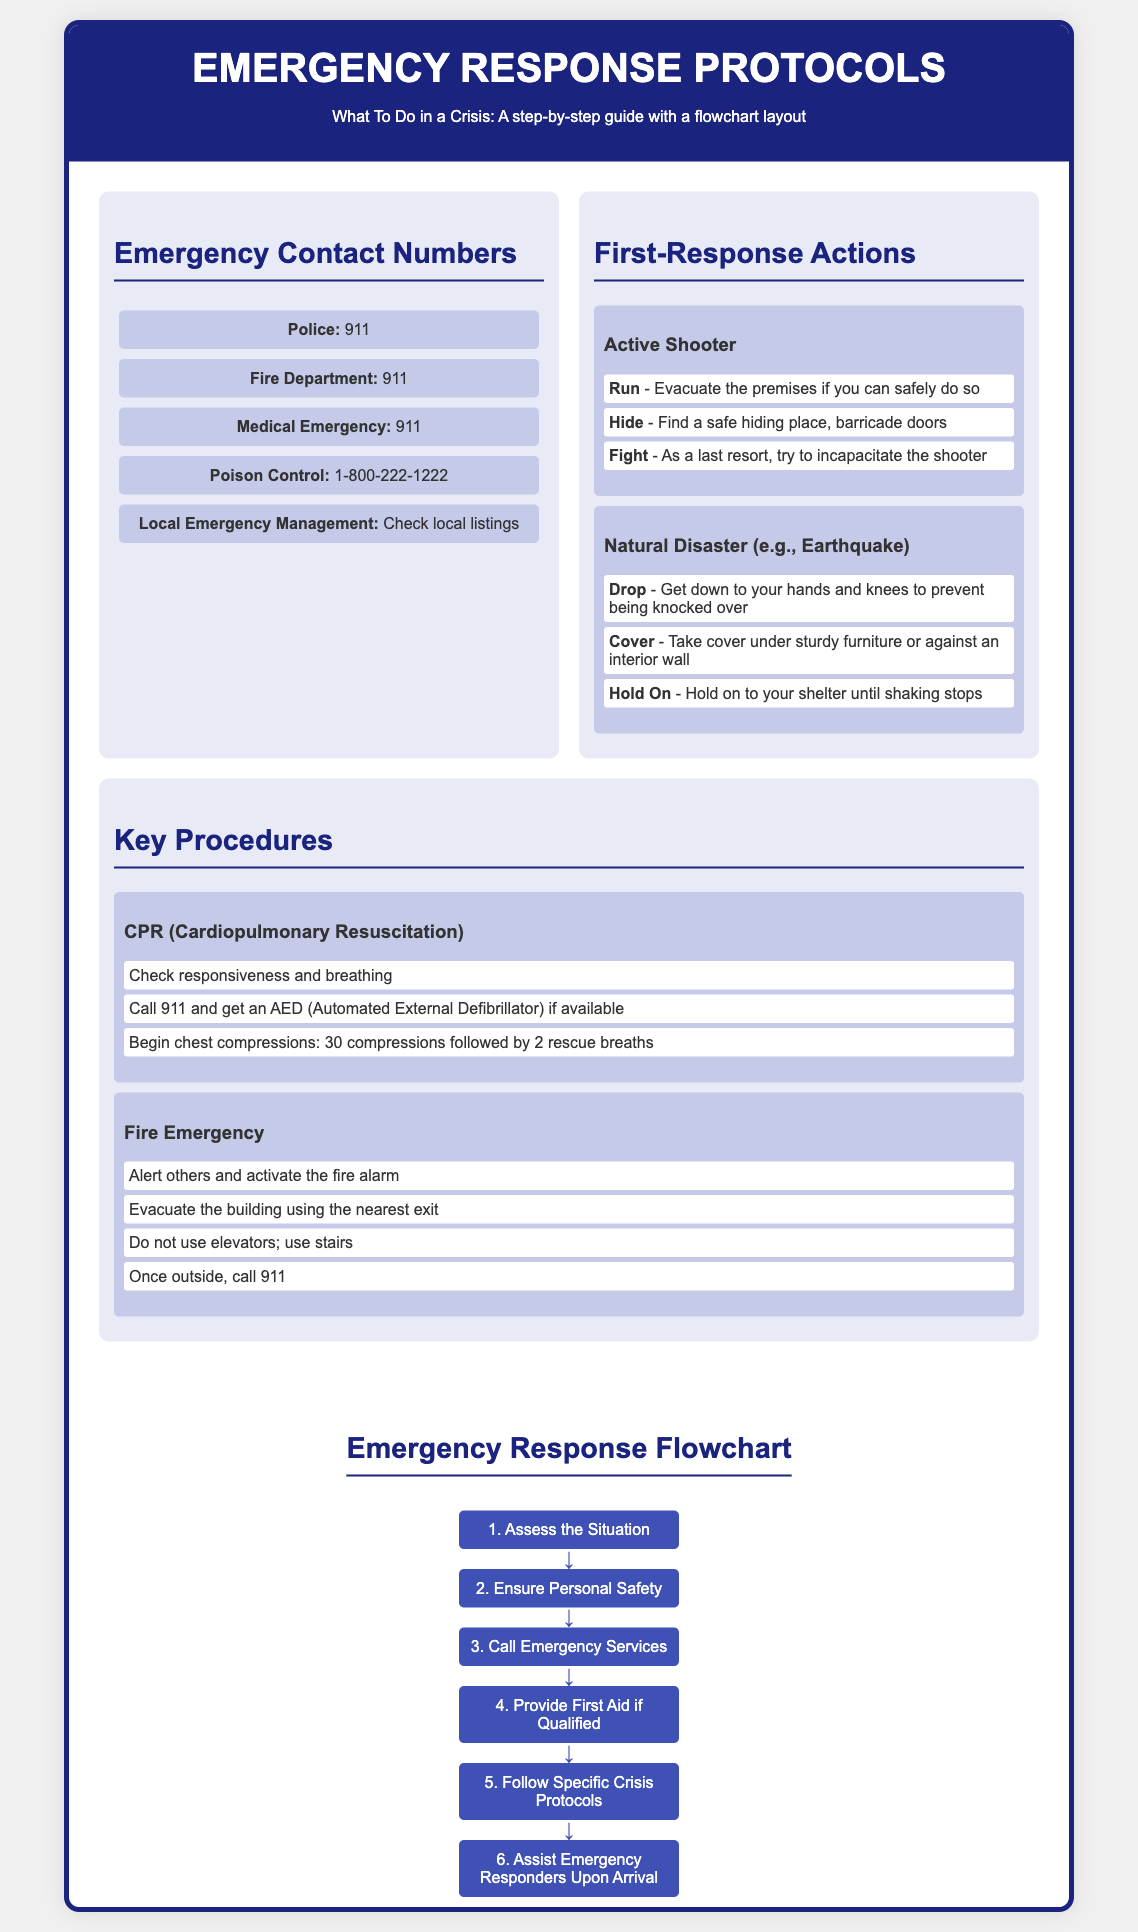What is the emergency number for police? The poster lists the police emergency number as 911.
Answer: 911 What are the first three actions to take in an active shooter situation? The steps are run, hide, and fight according to the poster.
Answer: Run, hide, fight How many steps are outlined for CPR? The procedure for CPR includes three steps as indicated in the document.
Answer: Three Which number should you call for poison control? The poster states the number for poison control is 1-800-222-1222.
Answer: 1-800-222-1222 What is the second step in the emergency response flowchart? The second step listed in the flowchart is to ensure personal safety.
Answer: Ensure personal safety Which procedure includes activating the fire alarm? The fire emergency procedure involves activating the fire alarm according to the document.
Answer: Fire Emergency What should you do during an earthquake according to the guidelines? The guidelines recommend dropping, covering, and holding on during an earthquake.
Answer: Drop, cover, hold on What type of document is this? The document is a poster specifically designed to provide emergency response protocols.
Answer: Poster 